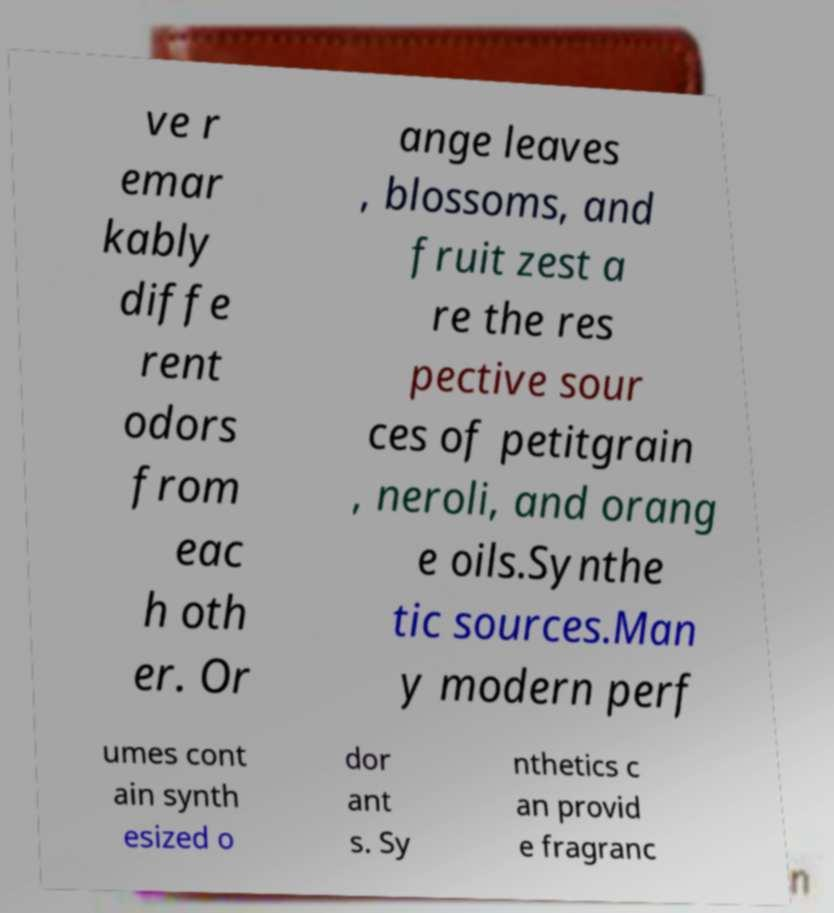Please identify and transcribe the text found in this image. ve r emar kably diffe rent odors from eac h oth er. Or ange leaves , blossoms, and fruit zest a re the res pective sour ces of petitgrain , neroli, and orang e oils.Synthe tic sources.Man y modern perf umes cont ain synth esized o dor ant s. Sy nthetics c an provid e fragranc 